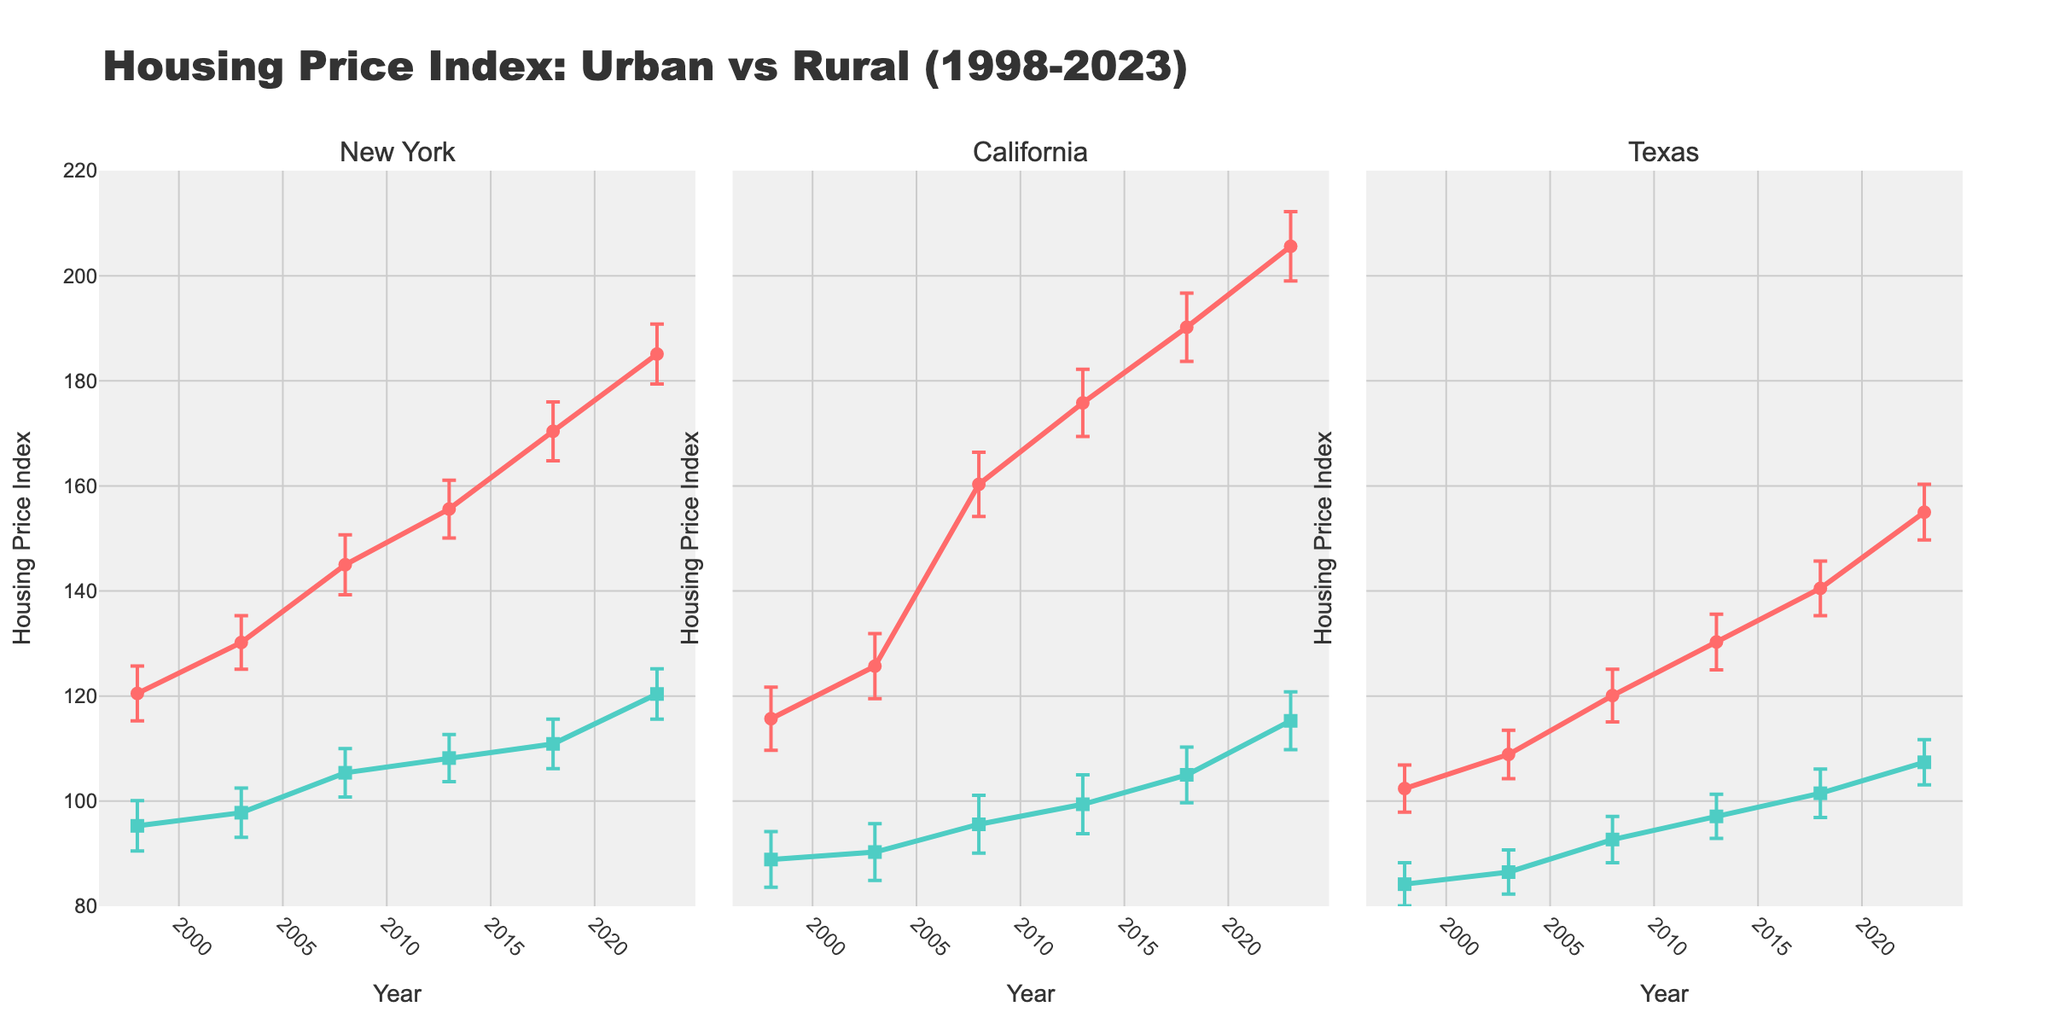How is the overall trend of urban housing prices in New York over the last 25 years? The urban housing price index in New York consistently increased from 120.5 in 1998 to 185.1 in 2023. This shows a steady rising trend.
Answer: The trend is upward What can be observed from the error margins of urban housing prices in California? The error margins for urban housing prices in California are around 6 from 1998 to 2023, showing relative consistency over the years.
Answer: Consistent error margins around 6 Which region had the lowest rural housing price index in 2018? The rural housing price index for 2018 is shown in three separate plots. New York had 110.9, California had 105.0, and Texas had 101.5. Texas had the lowest rural index.
Answer: Texas What is the difference in urban housing prices between New York and California in 2023? In 2023, the urban housing price index in New York is 185.1, while in California, it is 205.6. The difference is 205.6 - 185.1.
Answer: 20.5 Which region had the highest increase in urban housing prices from 1998 to 2023? The increases from 1998 to 2023 are: New York (185.1 - 120.5 = 64.6), California (205.6 - 115.7 = 89.9), and Texas (155.0 - 102.4 = 52.6). California had the highest increase.
Answer: California Are the rural housing prices in Texas higher or lower than urban housing prices in New York in 2023? In 2023, the rural housing price index in Texas is 107.4, and the urban housing price index in New York is 185.1. The rural prices in Texas are lower.
Answer: Lower Which year shows the biggest gap between urban and rural housing prices in California? For each year, the gaps are: 
1998 (115.7 - 88.9 = 26.8),  
2003 (125.7 - 90.3 = 35.4),  
2008 (160.3 - 95.6 = 64.7),  
2013 (175.8 - 99.4 = 76.4),  
2018 (190.2 - 105.0 = 85.2),  
2023 (205.6 - 115.3 = 90.3).  
The year 2023 has the biggest gap.
Answer: 2023 How do the error margins for rural housing prices compare between New York and Texas in 1998? In 1998, New York's rural error margin is 4.8, and Texas's rural error margin is 4.1. New York's error margin is slightly higher.
Answer: New York's is higher What is the average rural housing price index of California over the years provided? The rural indices provided for California are 88.9, 90.3, 95.6, 99.4, 105.0, and 115.3. The average is (88.9 + 90.3 + 95.6 + 99.4 + 105.0 + 115.3)/6.
Answer: 99.1 Between New York, California, and Texas, which region's urban housing prices have the smallest error margin in 2023? In 2023, the urban error margins are: New York (5.7), California (6.6), and Texas (5.3). Texas has the smallest error margin.
Answer: Texas 